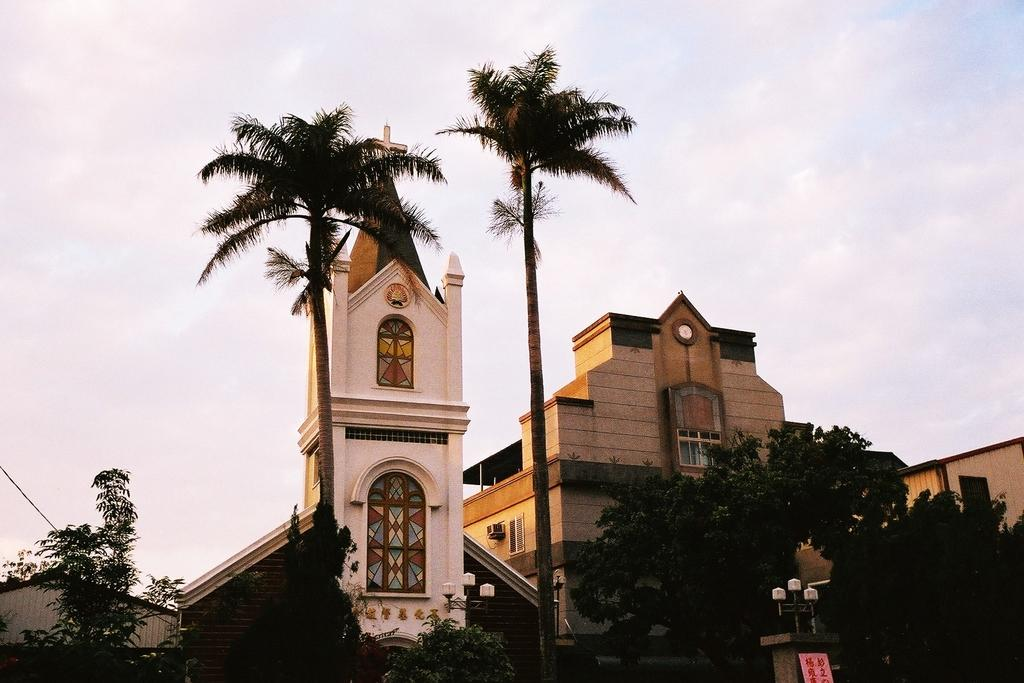What type of structures can be seen in the image? There are buildings in the image. What other natural elements are present in the image? There are trees in the image. Can you describe any specific features of the buildings? There are lights on stone pillars in the image. What is visible in the sky in the image? There are clouds in the sky in the image. What is the tendency of the celery to grow in the image? There is no celery present in the image, so it is not possible to determine its tendency to grow. 